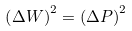Convert formula to latex. <formula><loc_0><loc_0><loc_500><loc_500>\left ( \Delta W \right ) ^ { 2 } = \left ( \Delta P \right ) ^ { 2 }</formula> 